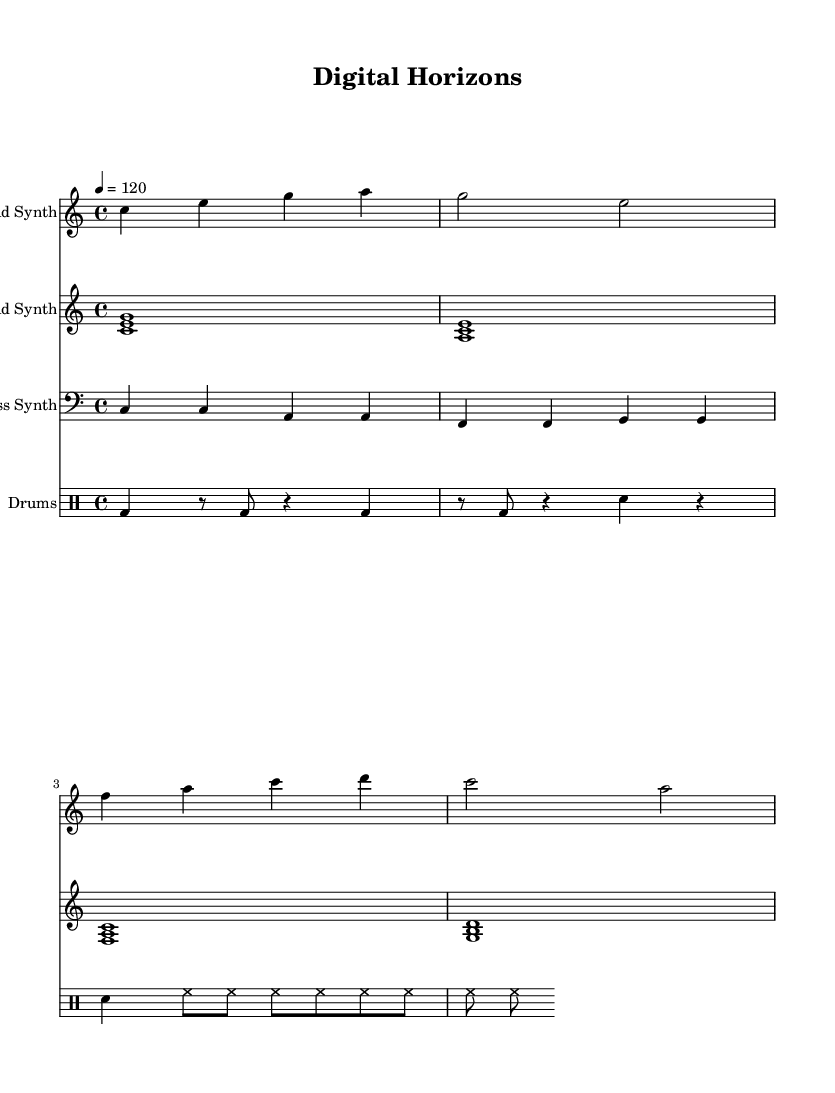What is the key signature of this music? The key signature is C major, which has no sharps or flats.
Answer: C major What is the time signature of this piece? The time signature indicated at the beginning is 4/4, meaning there are four beats in each measure.
Answer: 4/4 What is the tempo marking of the piece? The tempo marking stated in the score is quarter note equals 120 beats per minute, indicating the speed of the piece.
Answer: 120 How many measures are there in the lead synth part? By counting the measures in the lead synth staff, there are a total of four measures present.
Answer: 4 In what clef is the bass synth written? The bass synth staff specifies the bass clef, which is standard for lower pitch instruments.
Answer: Bass Which instrument plays the harmonic pads? The staff labeled "Pad Synth" represents the instrument that plays the harmonic pads.
Answer: Pad Synth What rhythmic pattern does the drum part predominantly feature? The drum pattern predominantly features a kick drum on the downbeat, aligning with the typical 4/4 pop rhythm structure.
Answer: Kick drum 